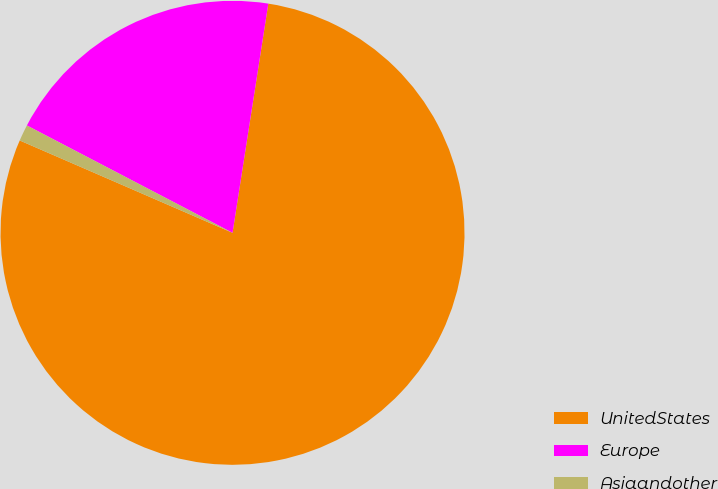Convert chart to OTSL. <chart><loc_0><loc_0><loc_500><loc_500><pie_chart><fcel>UnitedStates<fcel>Europe<fcel>Asiaandother<nl><fcel>79.06%<fcel>19.81%<fcel>1.14%<nl></chart> 